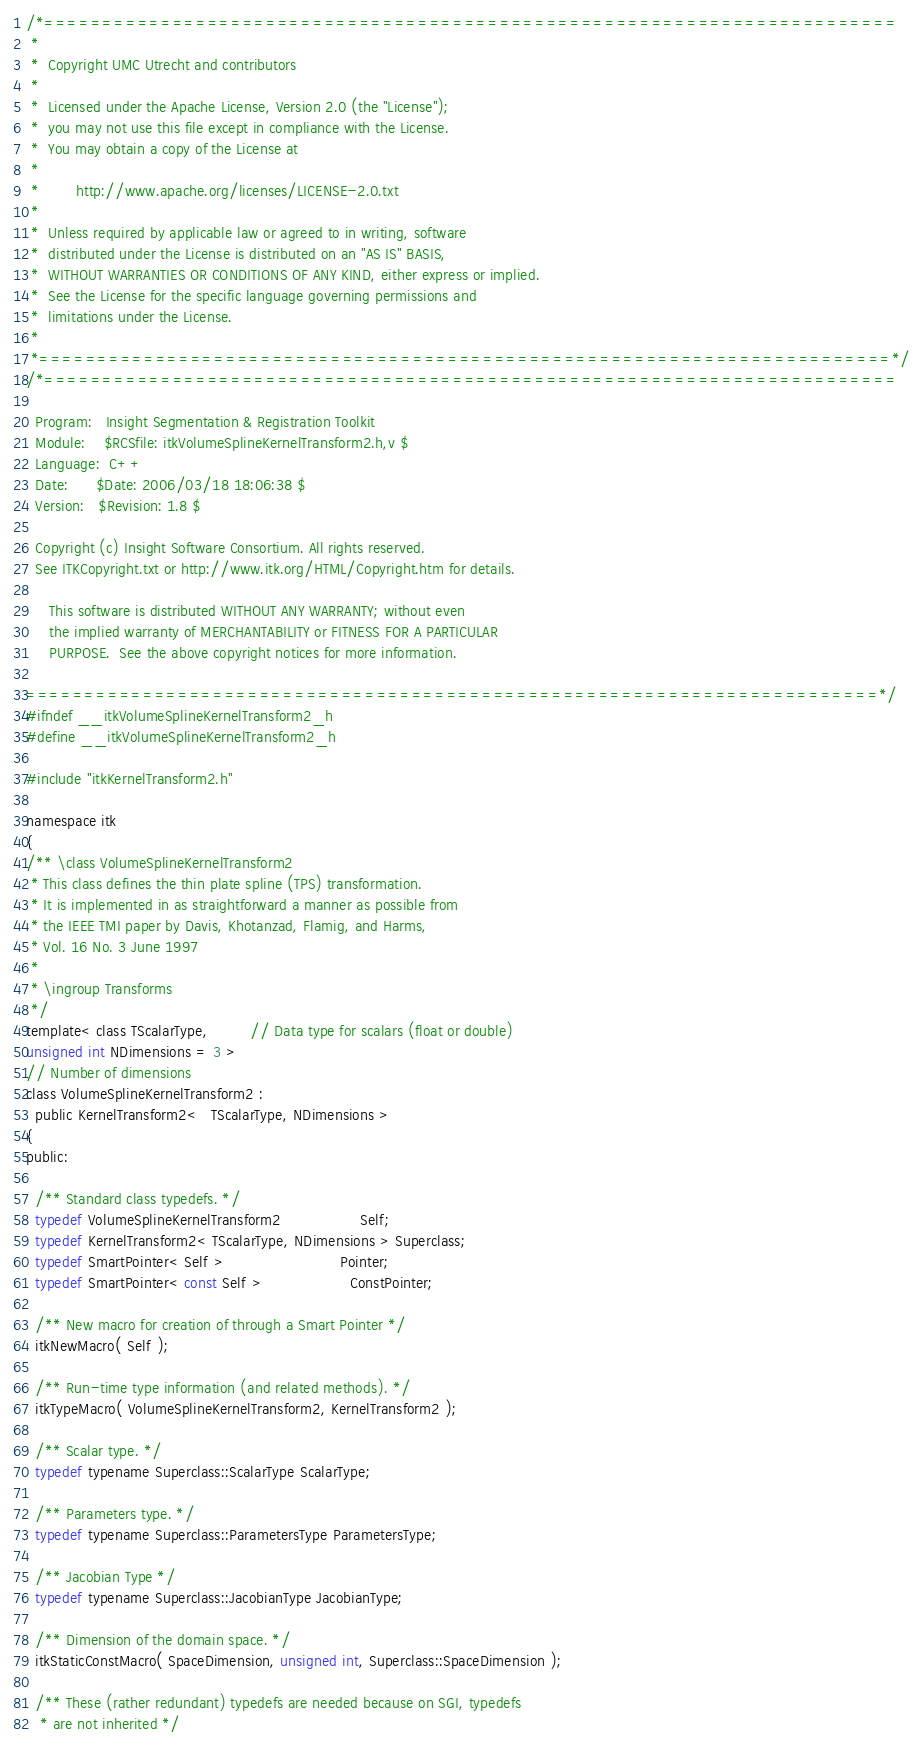<code> <loc_0><loc_0><loc_500><loc_500><_C_>/*=========================================================================
 *
 *  Copyright UMC Utrecht and contributors
 *
 *  Licensed under the Apache License, Version 2.0 (the "License");
 *  you may not use this file except in compliance with the License.
 *  You may obtain a copy of the License at
 *
 *        http://www.apache.org/licenses/LICENSE-2.0.txt
 *
 *  Unless required by applicable law or agreed to in writing, software
 *  distributed under the License is distributed on an "AS IS" BASIS,
 *  WITHOUT WARRANTIES OR CONDITIONS OF ANY KIND, either express or implied.
 *  See the License for the specific language governing permissions and
 *  limitations under the License.
 *
 *=========================================================================*/
/*=========================================================================

  Program:   Insight Segmentation & Registration Toolkit
  Module:    $RCSfile: itkVolumeSplineKernelTransform2.h,v $
  Language:  C++
  Date:      $Date: 2006/03/18 18:06:38 $
  Version:   $Revision: 1.8 $

  Copyright (c) Insight Software Consortium. All rights reserved.
  See ITKCopyright.txt or http://www.itk.org/HTML/Copyright.htm for details.

     This software is distributed WITHOUT ANY WARRANTY; without even
     the implied warranty of MERCHANTABILITY or FITNESS FOR A PARTICULAR
     PURPOSE.  See the above copyright notices for more information.

=========================================================================*/
#ifndef __itkVolumeSplineKernelTransform2_h
#define __itkVolumeSplineKernelTransform2_h

#include "itkKernelTransform2.h"

namespace itk
{
/** \class VolumeSplineKernelTransform2
 * This class defines the thin plate spline (TPS) transformation.
 * It is implemented in as straightforward a manner as possible from
 * the IEEE TMI paper by Davis, Khotanzad, Flamig, and Harms,
 * Vol. 16 No. 3 June 1997
 *
 * \ingroup Transforms
 */
template< class TScalarType,         // Data type for scalars (float or double)
unsigned int NDimensions = 3 >
// Number of dimensions
class VolumeSplineKernelTransform2 :
  public KernelTransform2<   TScalarType, NDimensions >
{
public:

  /** Standard class typedefs. */
  typedef VolumeSplineKernelTransform2                 Self;
  typedef KernelTransform2< TScalarType, NDimensions > Superclass;
  typedef SmartPointer< Self >                         Pointer;
  typedef SmartPointer< const Self >                   ConstPointer;

  /** New macro for creation of through a Smart Pointer */
  itkNewMacro( Self );

  /** Run-time type information (and related methods). */
  itkTypeMacro( VolumeSplineKernelTransform2, KernelTransform2 );

  /** Scalar type. */
  typedef typename Superclass::ScalarType ScalarType;

  /** Parameters type. */
  typedef typename Superclass::ParametersType ParametersType;

  /** Jacobian Type */
  typedef typename Superclass::JacobianType JacobianType;

  /** Dimension of the domain space. */
  itkStaticConstMacro( SpaceDimension, unsigned int, Superclass::SpaceDimension );

  /** These (rather redundant) typedefs are needed because on SGI, typedefs
   * are not inherited */</code> 